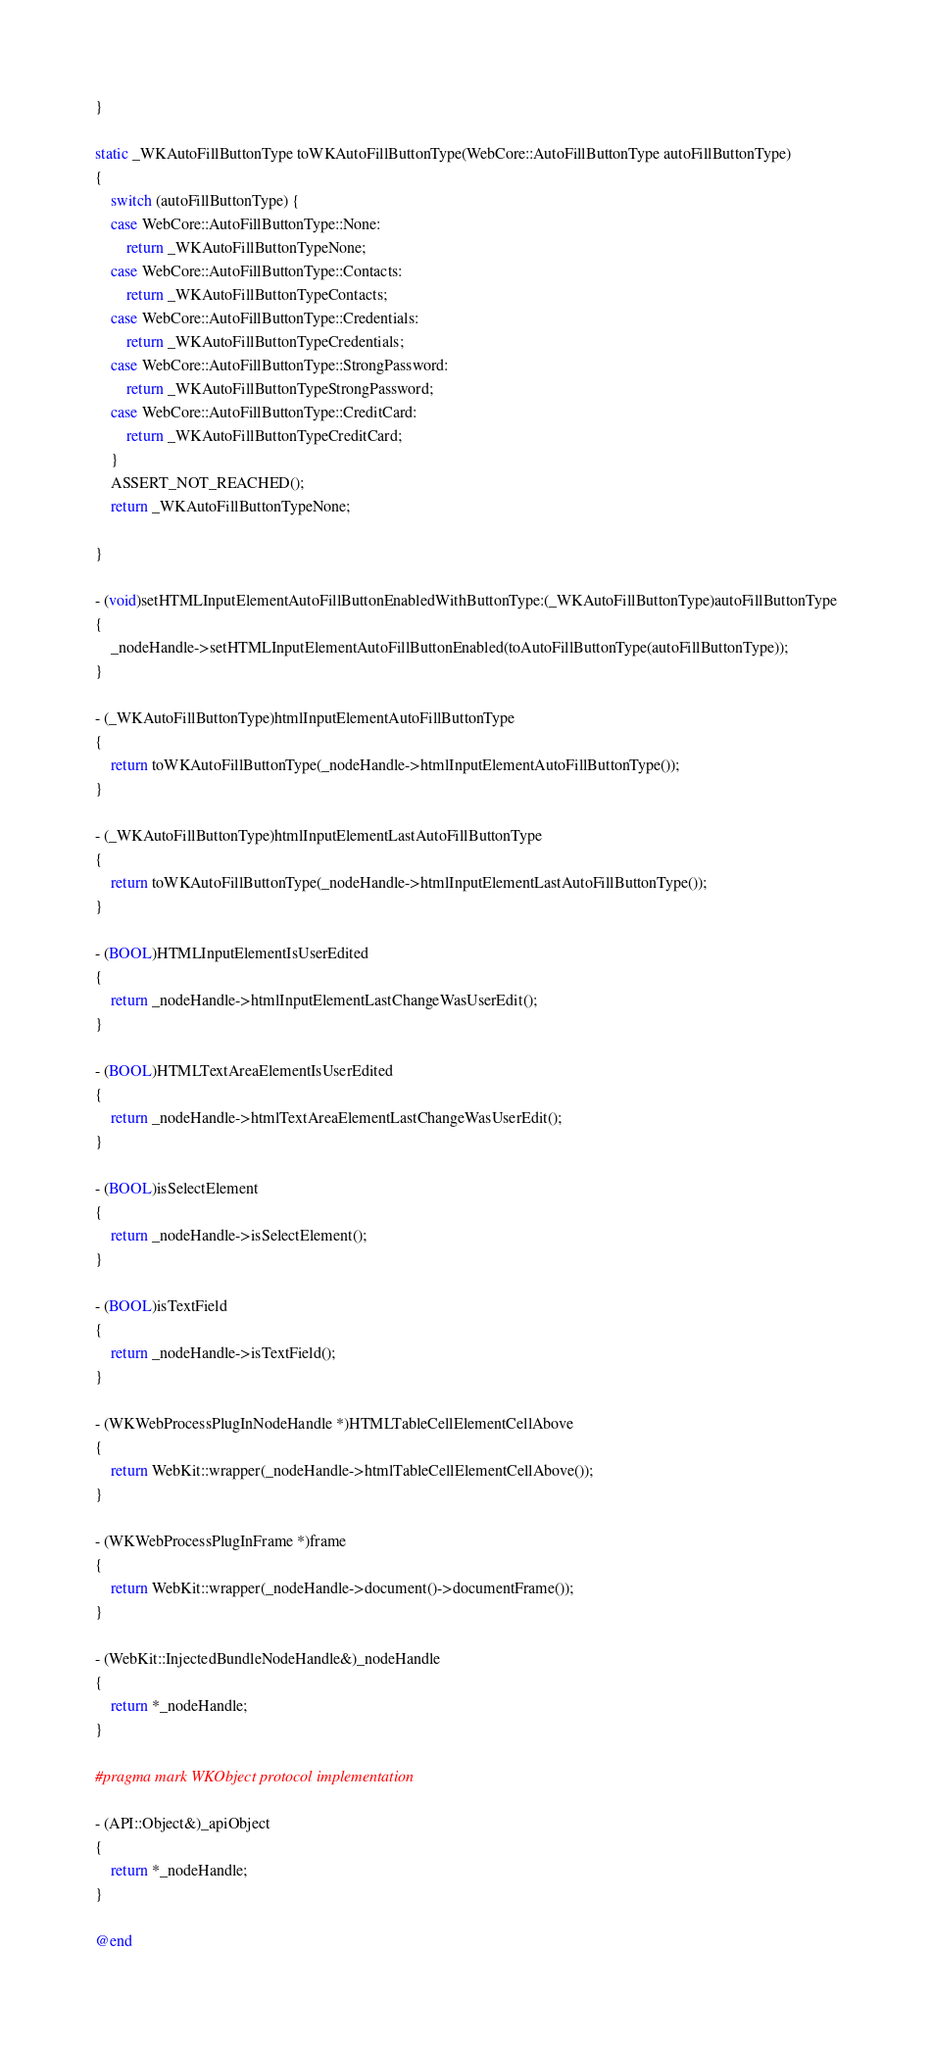Convert code to text. <code><loc_0><loc_0><loc_500><loc_500><_ObjectiveC_>}

static _WKAutoFillButtonType toWKAutoFillButtonType(WebCore::AutoFillButtonType autoFillButtonType)
{
    switch (autoFillButtonType) {
    case WebCore::AutoFillButtonType::None:
        return _WKAutoFillButtonTypeNone;
    case WebCore::AutoFillButtonType::Contacts:
        return _WKAutoFillButtonTypeContacts;
    case WebCore::AutoFillButtonType::Credentials:
        return _WKAutoFillButtonTypeCredentials;
    case WebCore::AutoFillButtonType::StrongPassword:
        return _WKAutoFillButtonTypeStrongPassword;
    case WebCore::AutoFillButtonType::CreditCard:
        return _WKAutoFillButtonTypeCreditCard;
    }
    ASSERT_NOT_REACHED();
    return _WKAutoFillButtonTypeNone;

}

- (void)setHTMLInputElementAutoFillButtonEnabledWithButtonType:(_WKAutoFillButtonType)autoFillButtonType
{
    _nodeHandle->setHTMLInputElementAutoFillButtonEnabled(toAutoFillButtonType(autoFillButtonType));
}

- (_WKAutoFillButtonType)htmlInputElementAutoFillButtonType
{
    return toWKAutoFillButtonType(_nodeHandle->htmlInputElementAutoFillButtonType());
}

- (_WKAutoFillButtonType)htmlInputElementLastAutoFillButtonType
{
    return toWKAutoFillButtonType(_nodeHandle->htmlInputElementLastAutoFillButtonType());
}

- (BOOL)HTMLInputElementIsUserEdited
{
    return _nodeHandle->htmlInputElementLastChangeWasUserEdit();
}

- (BOOL)HTMLTextAreaElementIsUserEdited
{
    return _nodeHandle->htmlTextAreaElementLastChangeWasUserEdit();
}

- (BOOL)isSelectElement
{
    return _nodeHandle->isSelectElement();
}

- (BOOL)isTextField
{
    return _nodeHandle->isTextField();
}

- (WKWebProcessPlugInNodeHandle *)HTMLTableCellElementCellAbove
{
    return WebKit::wrapper(_nodeHandle->htmlTableCellElementCellAbove());
}

- (WKWebProcessPlugInFrame *)frame
{
    return WebKit::wrapper(_nodeHandle->document()->documentFrame());
}

- (WebKit::InjectedBundleNodeHandle&)_nodeHandle
{
    return *_nodeHandle;
}

#pragma mark WKObject protocol implementation

- (API::Object&)_apiObject
{
    return *_nodeHandle;
}

@end
</code> 